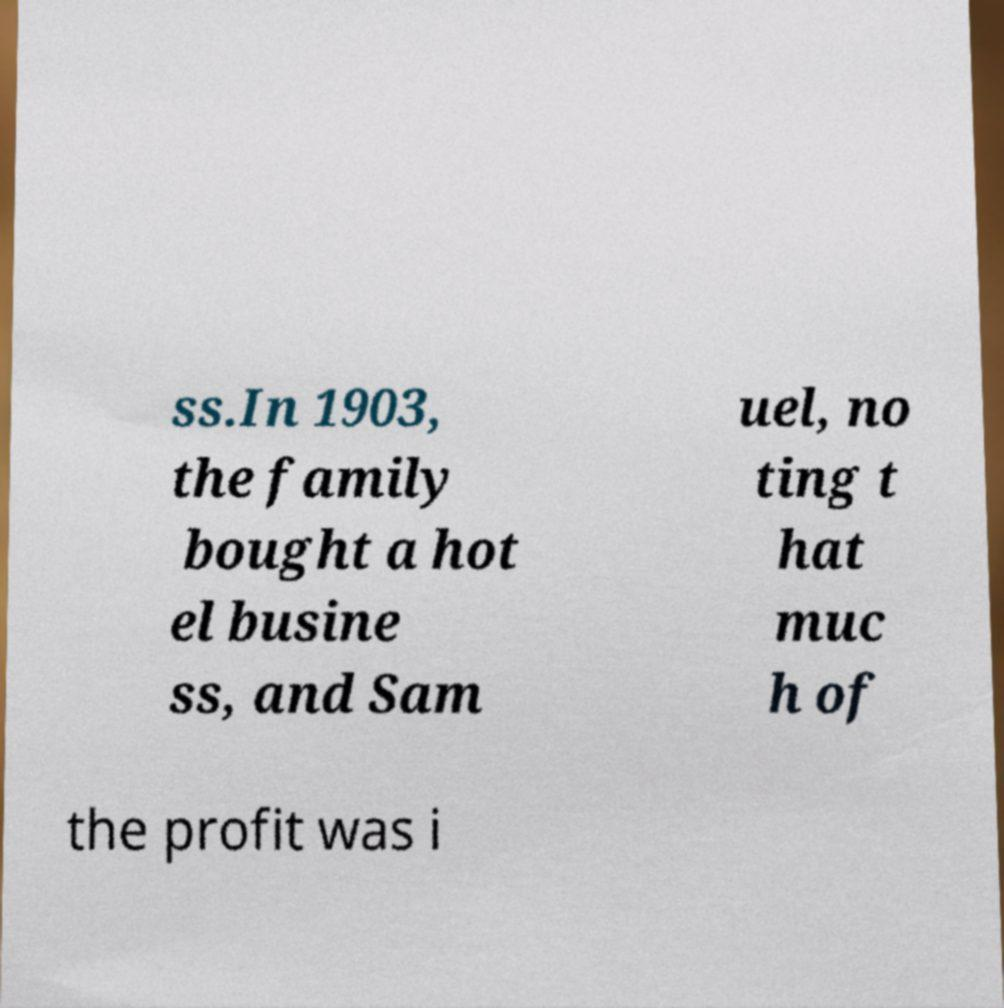Please read and relay the text visible in this image. What does it say? ss.In 1903, the family bought a hot el busine ss, and Sam uel, no ting t hat muc h of the profit was i 